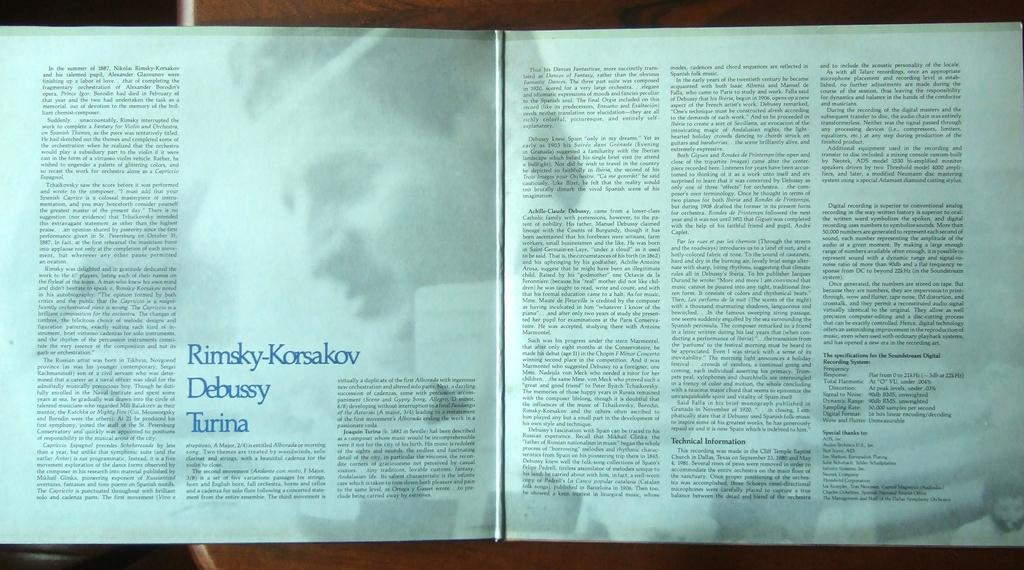<image>
Present a compact description of the photo's key features. An open book discussing the musicians Rimsky-Korsakov, Debussy, and Turina. 